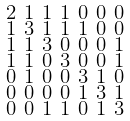Convert formula to latex. <formula><loc_0><loc_0><loc_500><loc_500>\begin{smallmatrix} 2 & 1 & 1 & 1 & 0 & 0 & 0 \\ 1 & 3 & 1 & 1 & 1 & 0 & 0 \\ 1 & 1 & 3 & 0 & 0 & 0 & 1 \\ 1 & 1 & 0 & 3 & 0 & 0 & 1 \\ 0 & 1 & 0 & 0 & 3 & 1 & 0 \\ 0 & 0 & 0 & 0 & 1 & 3 & 1 \\ 0 & 0 & 1 & 1 & 0 & 1 & 3 \end{smallmatrix}</formula> 